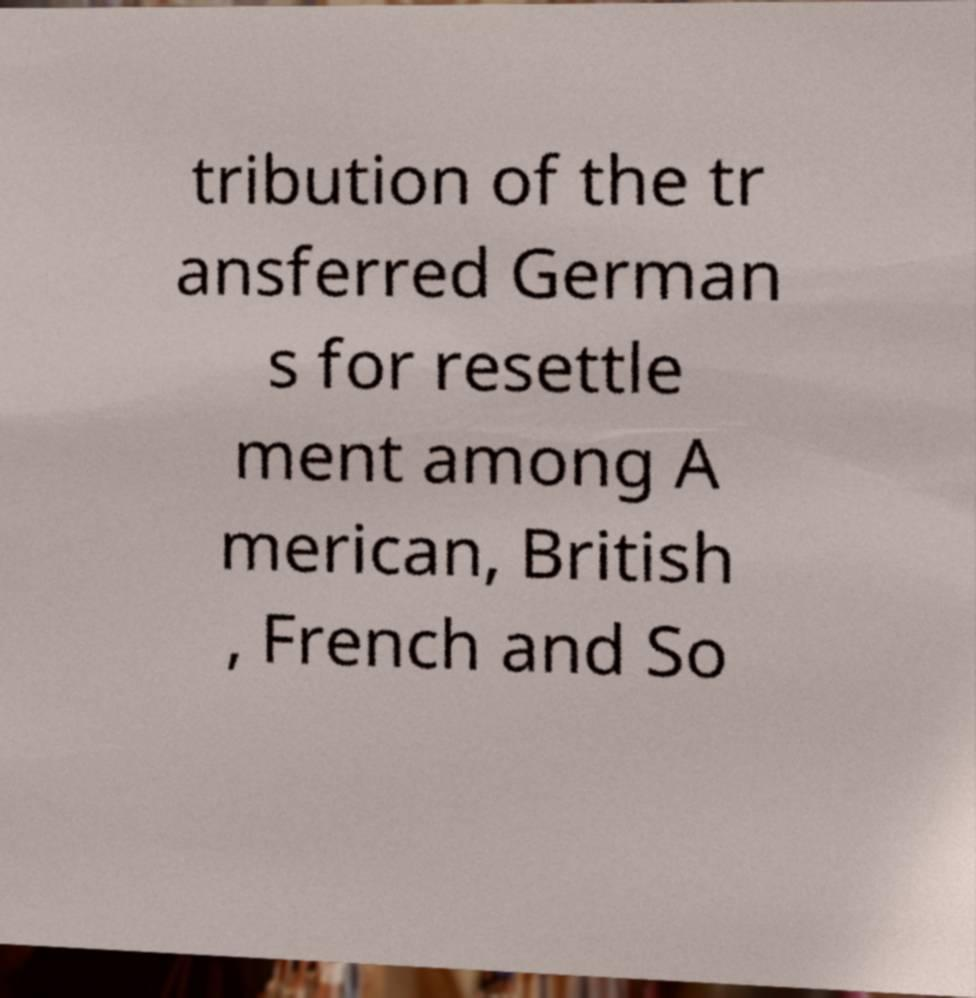What messages or text are displayed in this image? I need them in a readable, typed format. tribution of the tr ansferred German s for resettle ment among A merican, British , French and So 